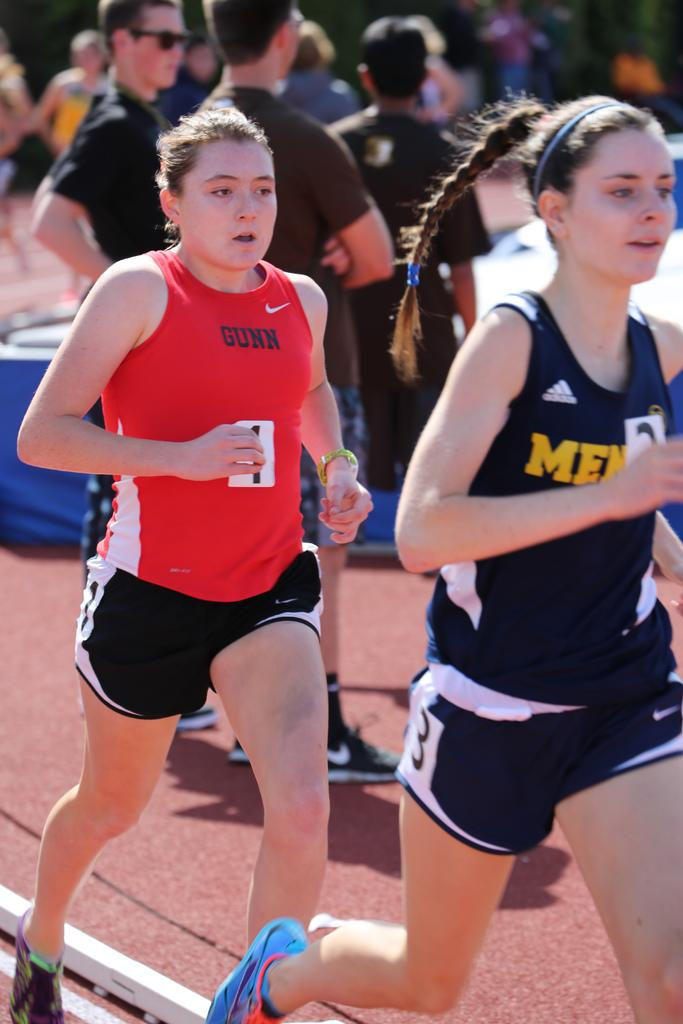<image>
Offer a succinct explanation of the picture presented. The second runner has Gunn written on her red Nike tank top. 